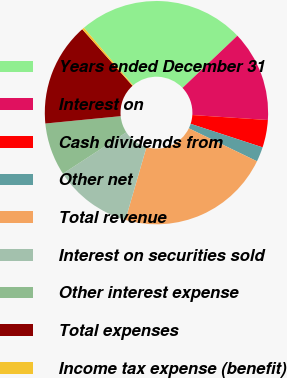Convert chart. <chart><loc_0><loc_0><loc_500><loc_500><pie_chart><fcel>Years ended December 31<fcel>Interest on<fcel>Cash dividends from<fcel>Other net<fcel>Total revenue<fcel>Interest on securities sold<fcel>Other interest expense<fcel>Total expenses<fcel>Income tax expense (benefit)<nl><fcel>24.16%<fcel>13.15%<fcel>3.98%<fcel>2.14%<fcel>22.32%<fcel>11.31%<fcel>7.65%<fcel>14.98%<fcel>0.31%<nl></chart> 